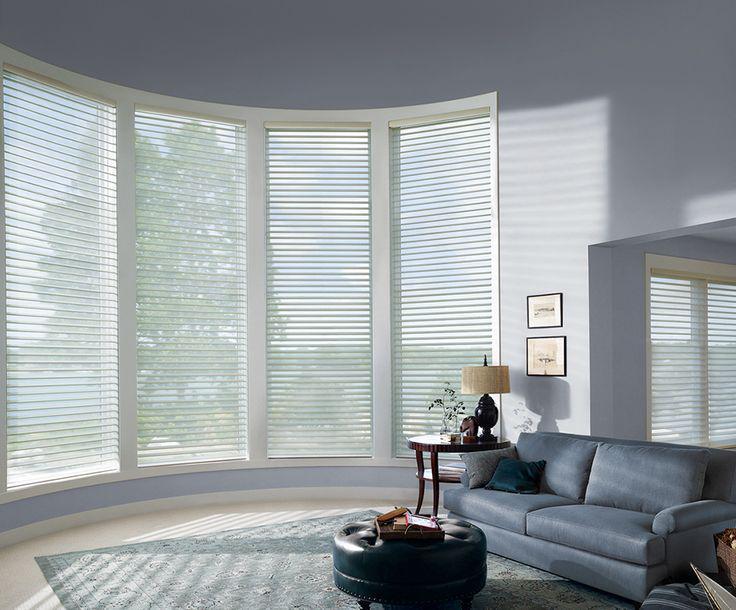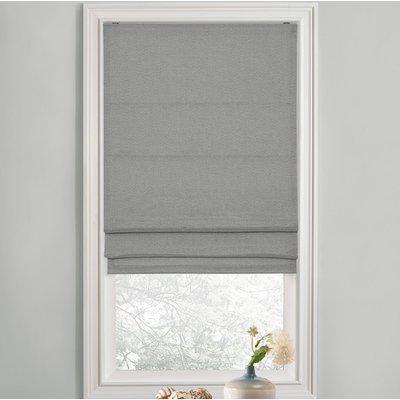The first image is the image on the left, the second image is the image on the right. Considering the images on both sides, is "A window shade is partially pulled up in the right image." valid? Answer yes or no. Yes. The first image is the image on the left, the second image is the image on the right. For the images displayed, is the sentence "There are five blinds." factually correct? Answer yes or no. Yes. 